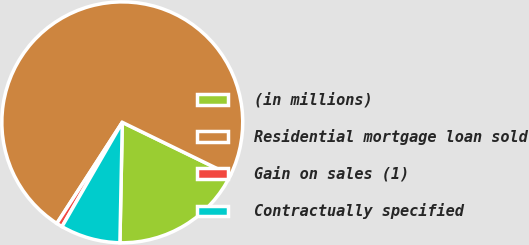Convert chart. <chart><loc_0><loc_0><loc_500><loc_500><pie_chart><fcel>(in millions)<fcel>Residential mortgage loan sold<fcel>Gain on sales (1)<fcel>Contractually specified<nl><fcel>18.1%<fcel>73.08%<fcel>0.8%<fcel>8.03%<nl></chart> 